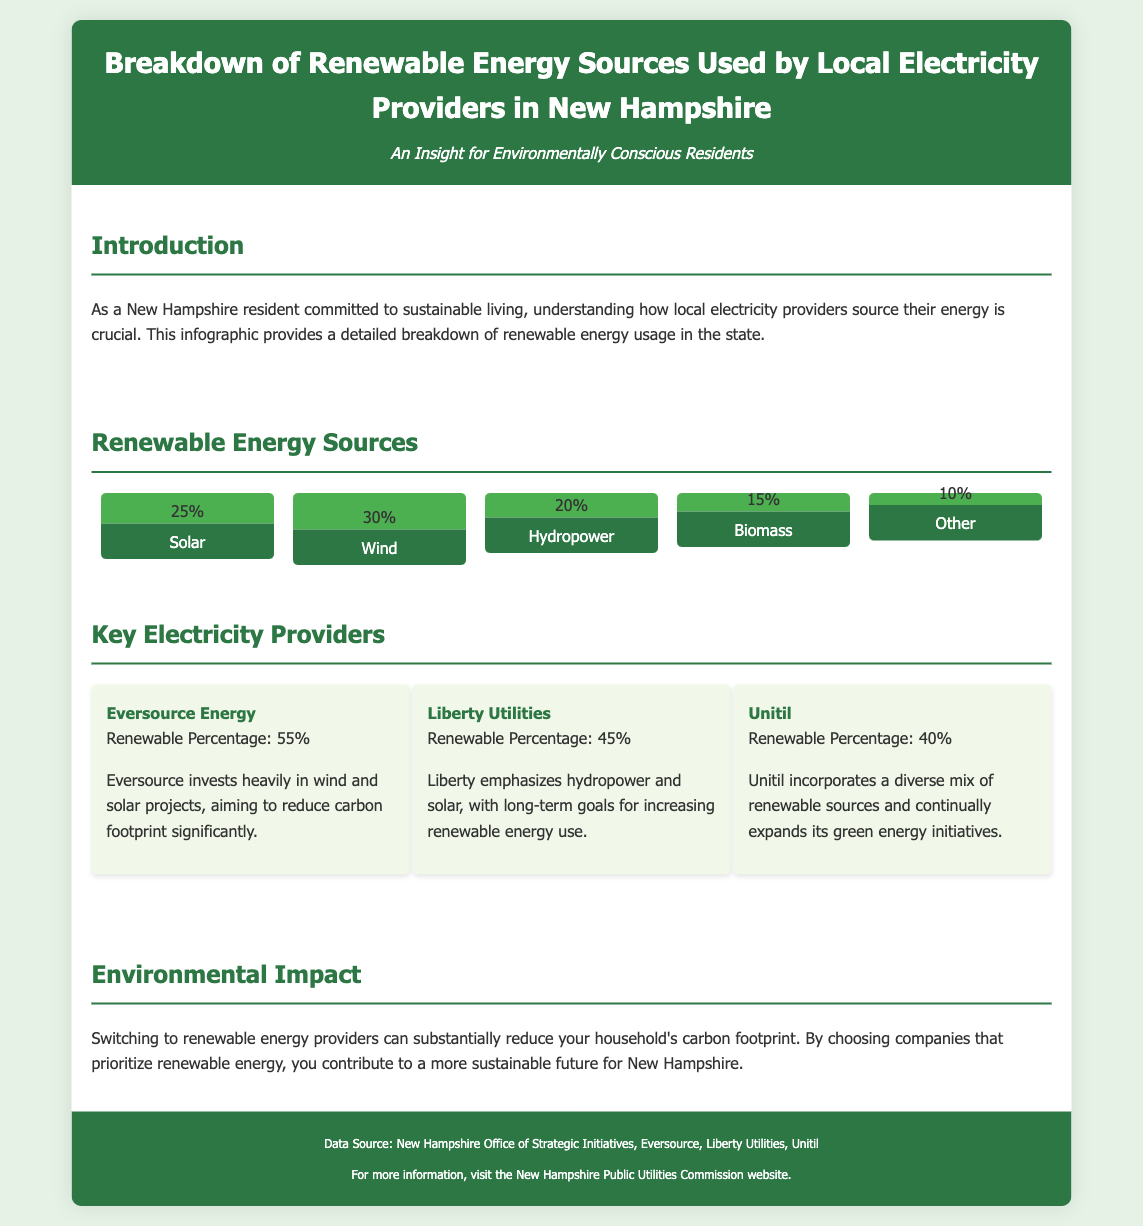What is the percentage of solar energy used? The infographic states that solar energy contributes 25% to the renewable sources.
Answer: 25% What is the highest renewable energy source percentage? The highest percentage is for wind energy, which is 30%.
Answer: 30% Who has the highest renewable percentage among electricity providers? Among the listed providers, Eversource Energy has the highest renewable percentage of 55%.
Answer: Eversource Energy What renewable energy source is at 15%? The document indicates that biomass accounts for 15% of the renewable energy sources.
Answer: Biomass What type of document is this? This document is an infographic presenting statistical data related to renewable energy sources and providers.
Answer: Infographic Which provider focuses heavily on wind and solar projects? Eversource Energy invests heavily in wind and solar projects, as mentioned in the document.
Answer: Eversource Energy What is the total renewable percentage for Liberty Utilities? Liberty Utilities has a renewable percentage of 45%, according to the infographic.
Answer: 45% Which renewable source has the lowest percentage? The renewable source with the lowest percentage is "Other" at 10%.
Answer: Other 